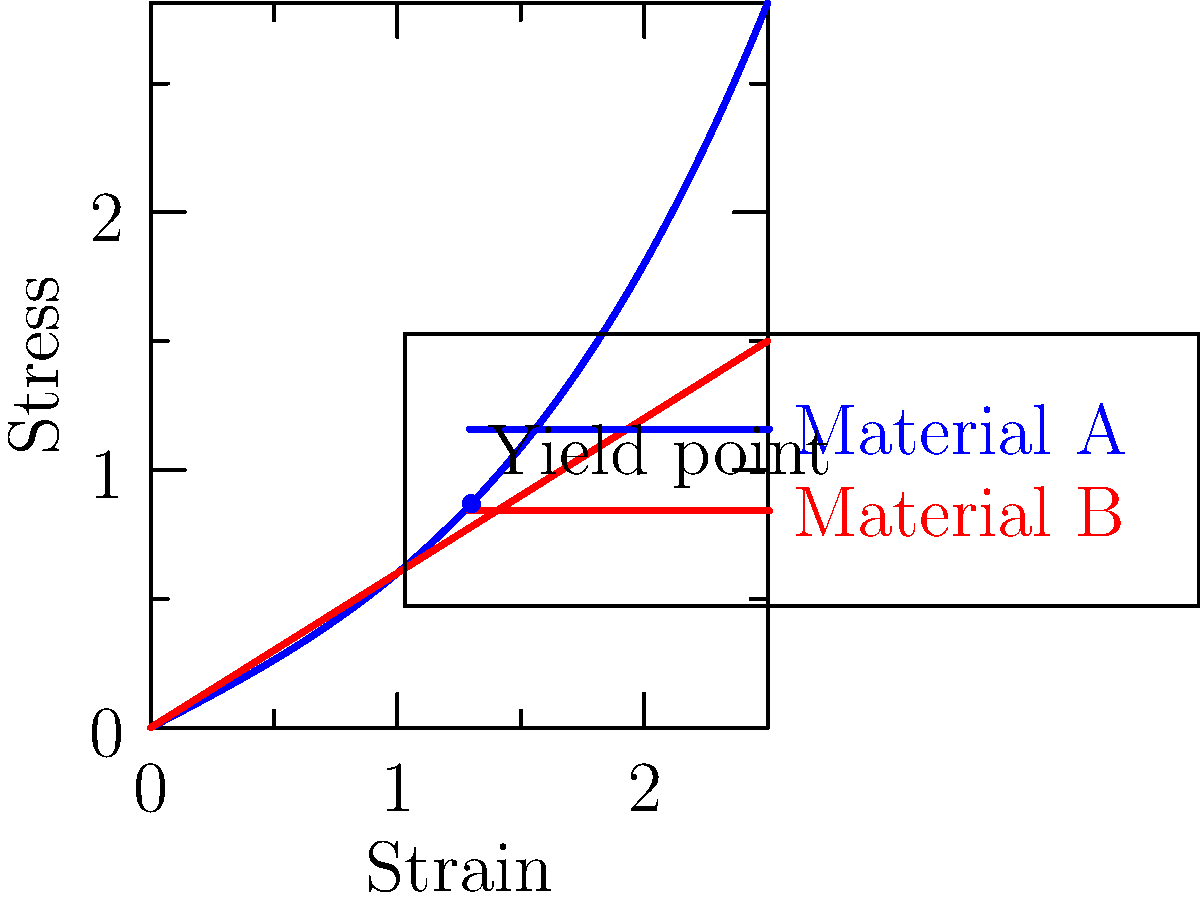In the stress-strain curve analysis shown for two materials used in orthopedic supports, which material would be more suitable for a flexible knee brace designed to provide both support and allow for a range of motion? Explain your reasoning based on the curve characteristics. To determine the most suitable material for a flexible knee brace, we need to analyze the stress-strain curves of both materials:

1. Material A (blue curve):
   - Exhibits a non-linear relationship between stress and strain
   - Shows an initial linear elastic region
   - Has a yield point, after which the curve becomes non-linear
   - Demonstrates higher stress values for given strain compared to Material B

2. Material B (red curve):
   - Shows a linear relationship between stress and strain
   - Does not exhibit a clear yield point
   - Has a lower slope, indicating lower stiffness compared to Material A

3. For a flexible knee brace:
   - We need a material that can provide support (some stiffness) but also allow for flexibility (ability to deform without permanent changes)
   - The material should be able to return to its original shape after stress is removed

4. Comparing the materials:
   - Material A's non-linear behavior after the yield point suggests it can undergo larger deformations without failing
   - The initial steeper slope of Material A indicates it provides more support at lower strains
   - Material A's ability to withstand higher stress levels means it can provide better support overall

5. Conclusion:
   Material A is more suitable for a flexible knee brace because it offers:
   - Better initial support (steeper initial slope)
   - Flexibility at higher strains (non-linear behavior after yield point)
   - Higher stress tolerance, indicating better durability

Material B, while more flexible overall, may not provide sufficient support for a knee brace application.
Answer: Material A 